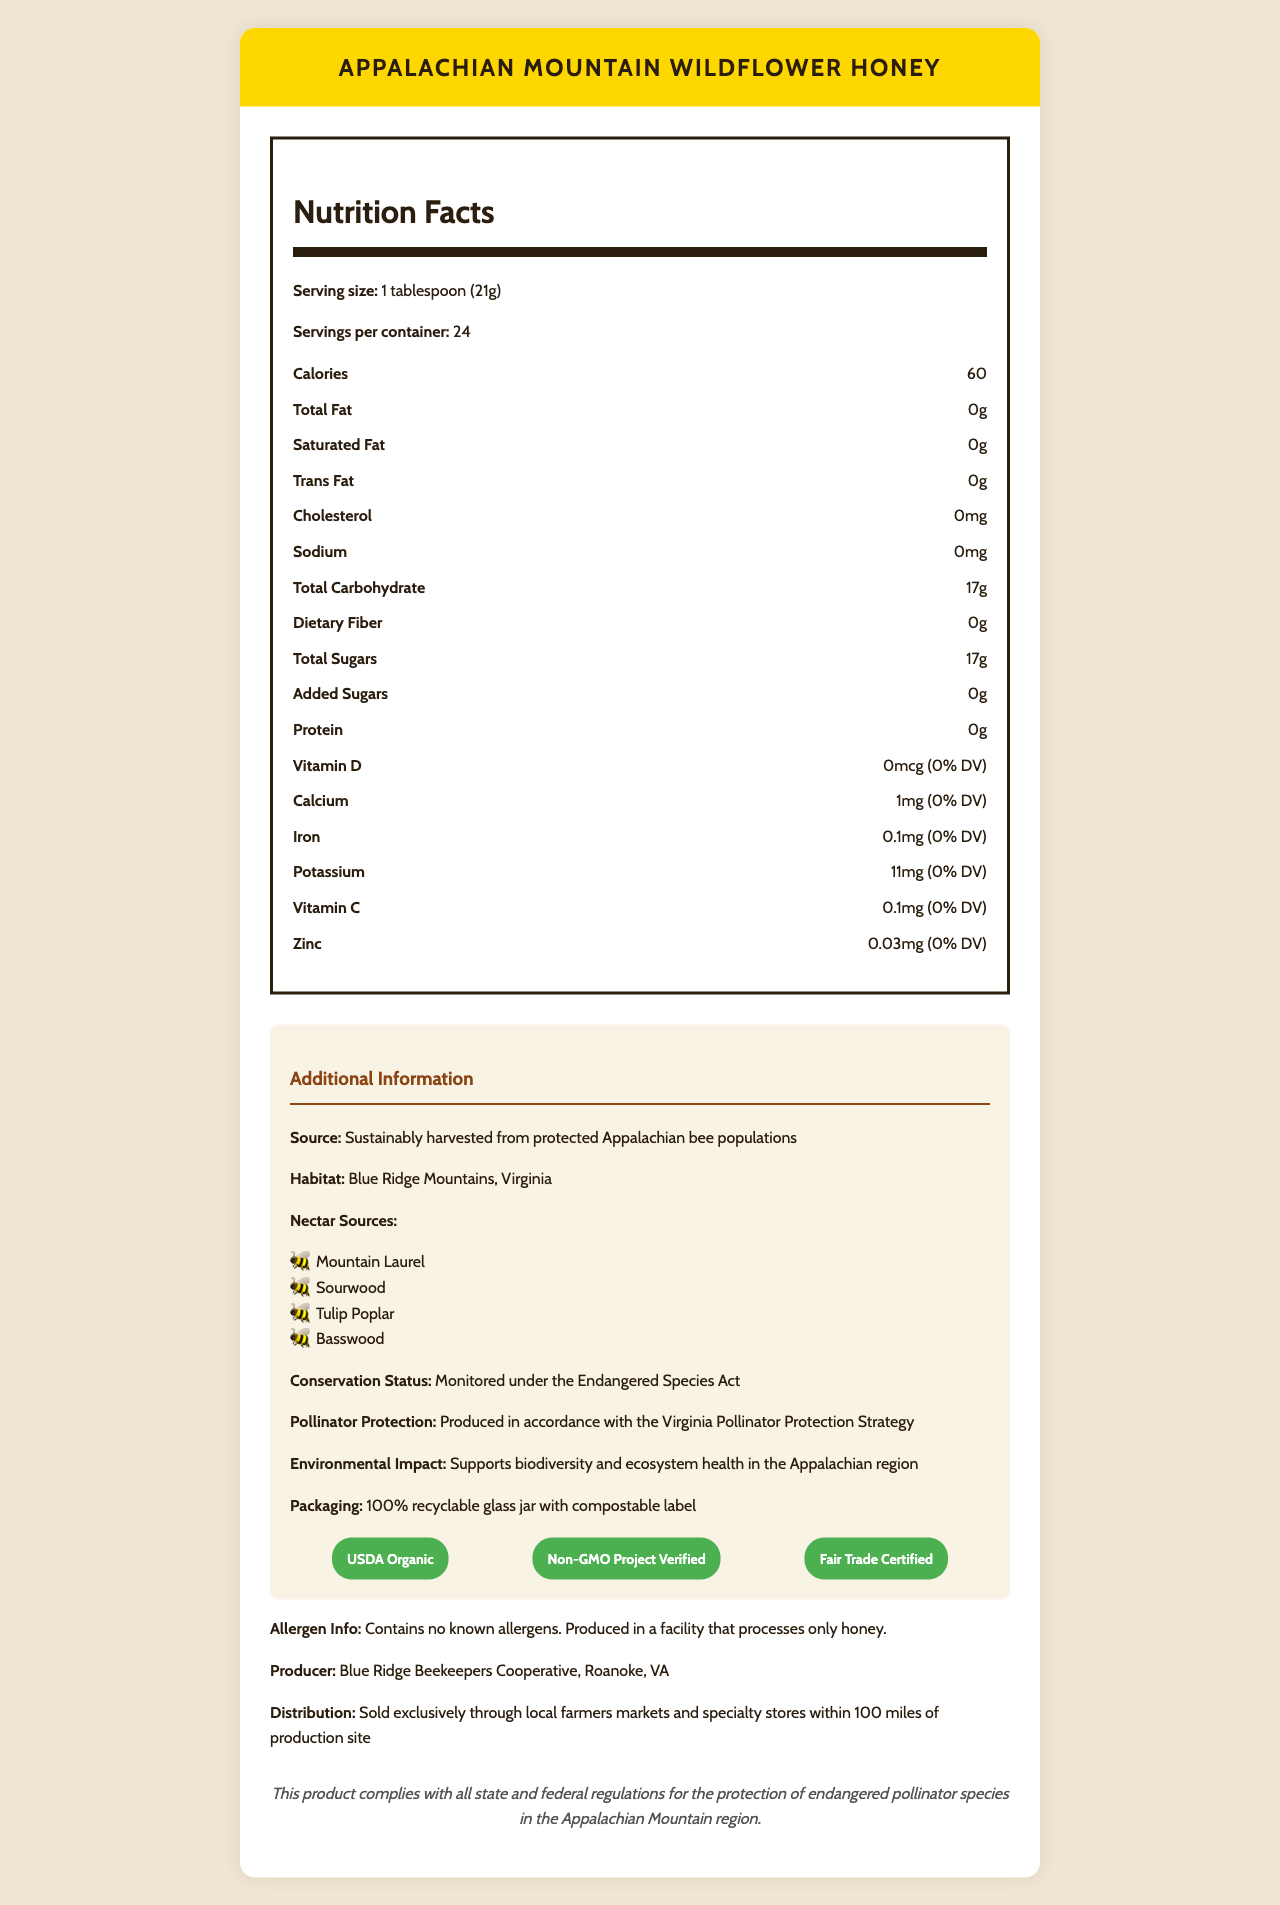what is the serving size of Appalachian Mountain Wildflower Honey? The document states the serving size explicitly as "1 tablespoon (21g)".
Answer: 1 tablespoon (21g) how many calories are in one serving of this honey? The calories per serving are listed as 60 in the Nutrition Facts section.
Answer: 60 what type of packaging is used for this honey? The document indicates under the additional information section that the packaging is a 100% recyclable glass jar with a compostable label.
Answer: 100% recyclable glass jar with compostable label where is the habitat of the bees that produce this honey? The habitat is listed as the Blue Ridge Mountains, Virginia, under the additional information section.
Answer: Blue Ridge Mountains, Virginia how many servings are there per container? The document specifies that there are 24 servings per container in the Nutrition Facts section.
Answer: 24 what is the source of this honey? A. Commercial Beekeeping Farms B. Wild Bees C. Sustainably harvested from protected Appalachian bee populations The additional information section clarifies that the honey is sustainably harvested from protected Appalachian bee populations.
Answer: C what certifications does this honey have? A. USDA Organic B. Non-GMO Project Verified C. Fair Trade Certified D. All of the above The document lists USDA Organic, Non-GMO Project Verified, and Fair Trade Certified as certifications.
Answer: D does this honey contain any added sugars? The Nutrition Facts states that there are 0 grams of added sugars.
Answer: No describe the general conservation and environmental efforts associated with this honey production. The document outlines several conservation efforts, including sustainable harvesting, adherence to the Endangered Species Act, pollinator protection strategies, and environmental packaging.
Answer: The honey is sustainably harvested from protected bee populations under the Endangered Species Act. It is produced in accordance with the Virginia Pollinator Protection Strategy, supports biodiversity, and aids in ecosystem health. The packaging is environmentally friendly, being 100% recyclable and compostable. how much protein is in one serving of this honey? The amount of protein per serving is listed as 0g in the Nutrition Facts.
Answer: 0g are there any allergens in this honey? The allergen information section specifies that the product contains no known allergens.
Answer: Contains no known allergens. what mineral is listed with the highest percentage of the daily value in this honey? A. Calcium B. Iron C. Potassium D. Zinc At 11mg, potassium has the highest absolute amount, but more importantly, it still reports not meeting 1% DV, indicating small traces relative to recommended intake values.
Answer: Potassium is the iron content in this honey significant enough to note? The iron content is only 0.1mg, which amounts to 0% of the daily value, indicating it is not a significant source of iron.
Answer: No what are the nectar sources listed for this honey? The nectar sources are directly listed under the additional information section.
Answer: Mountain Laurel, Sourwood, Tulip Poplar, Basswood is the producer of this honey a small cooperative, and where is it based? The document states that the producer is the Blue Ridge Beekeepers Cooperative based in Roanoke, VA.
Answer: Yes, Blue Ridge Beekeepers Cooperative, Roanoke, VA what is the total carbohydrate content per serving? The Nutrition Facts label lists the total carbohydrates as 17g per serving.
Answer: 17g what is the environmental impact of the honey production? The document mentions that the honey supports biodiversity and ecosystem health in the additional information section.
Answer: Supports biodiversity and ecosystem health in the Appalachian region how much zinc is in one serving, and what percentage of the daily value does it represent? The Nutrition Facts section lists zinc content as 0.03mg, which constitutes 0% of the daily value.
Answer: 0.03mg (0% DV) does the document provide information about the facility's hygiene standards? The document does not mention specific details about the facility's hygiene standards.
Answer: Not enough information 